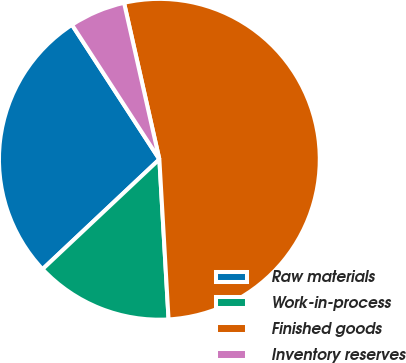<chart> <loc_0><loc_0><loc_500><loc_500><pie_chart><fcel>Raw materials<fcel>Work-in-process<fcel>Finished goods<fcel>Inventory reserves<nl><fcel>27.84%<fcel>13.9%<fcel>52.62%<fcel>5.64%<nl></chart> 